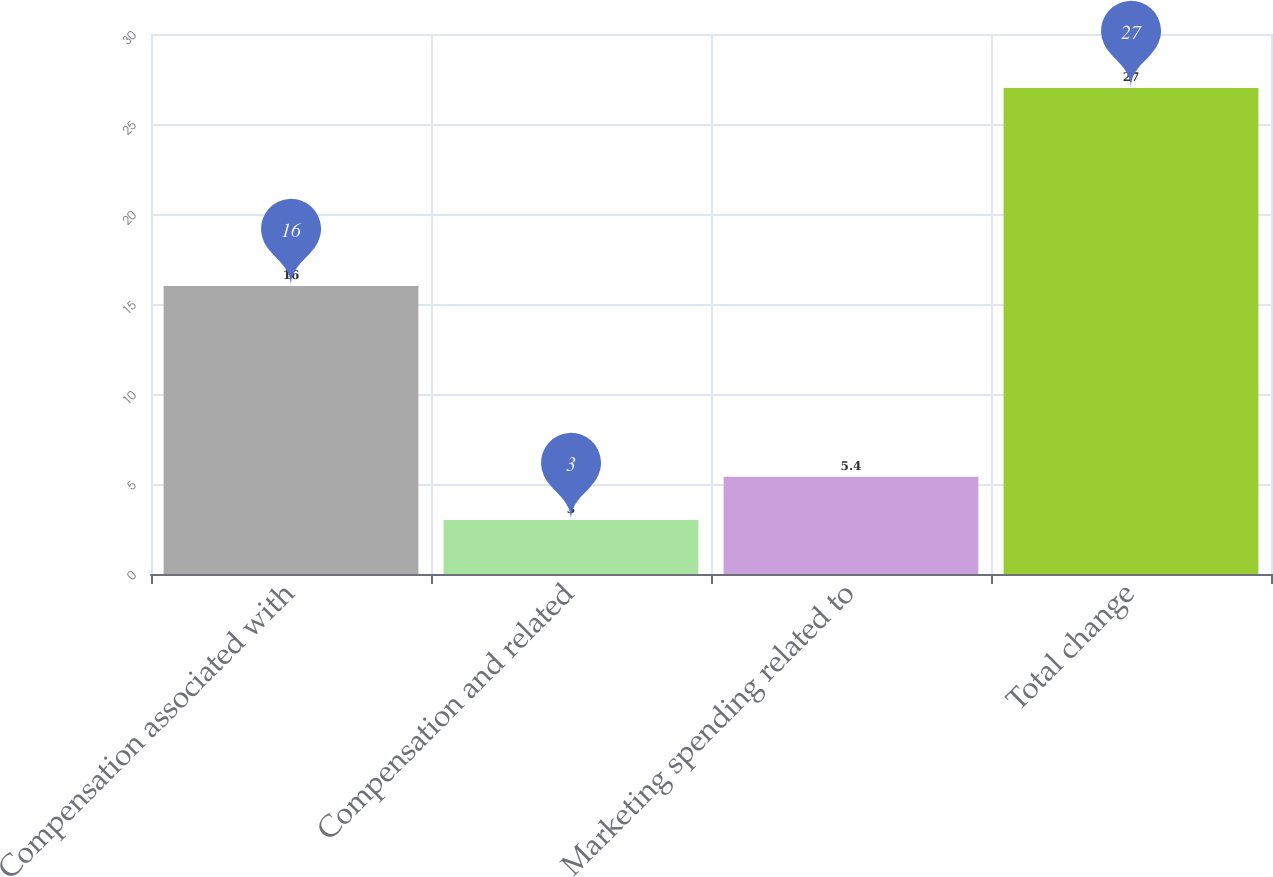Convert chart to OTSL. <chart><loc_0><loc_0><loc_500><loc_500><bar_chart><fcel>Compensation associated with<fcel>Compensation and related<fcel>Marketing spending related to<fcel>Total change<nl><fcel>16<fcel>3<fcel>5.4<fcel>27<nl></chart> 